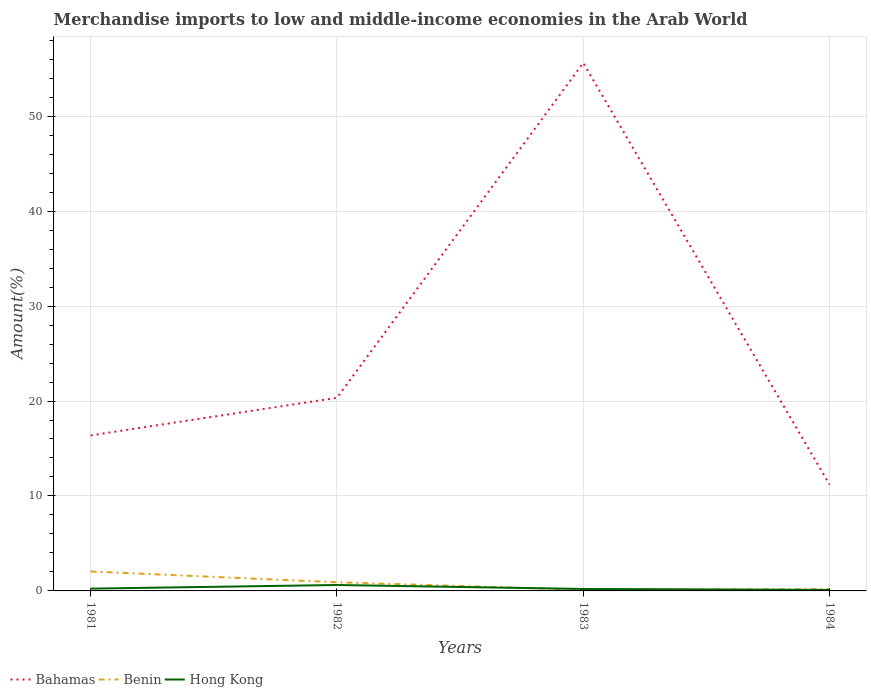How many different coloured lines are there?
Give a very brief answer. 3. Across all years, what is the maximum percentage of amount earned from merchandise imports in Bahamas?
Ensure brevity in your answer.  11.19. What is the total percentage of amount earned from merchandise imports in Hong Kong in the graph?
Offer a terse response. 0.52. What is the difference between the highest and the second highest percentage of amount earned from merchandise imports in Hong Kong?
Provide a short and direct response. 0.52. What is the difference between two consecutive major ticks on the Y-axis?
Ensure brevity in your answer.  10. Does the graph contain any zero values?
Offer a terse response. No. Does the graph contain grids?
Provide a succinct answer. Yes. How many legend labels are there?
Make the answer very short. 3. What is the title of the graph?
Your answer should be compact. Merchandise imports to low and middle-income economies in the Arab World. What is the label or title of the X-axis?
Keep it short and to the point. Years. What is the label or title of the Y-axis?
Give a very brief answer. Amount(%). What is the Amount(%) of Bahamas in 1981?
Your response must be concise. 16.38. What is the Amount(%) in Benin in 1981?
Your response must be concise. 2.05. What is the Amount(%) of Hong Kong in 1981?
Your answer should be very brief. 0.24. What is the Amount(%) in Bahamas in 1982?
Ensure brevity in your answer.  20.34. What is the Amount(%) of Benin in 1982?
Provide a short and direct response. 0.91. What is the Amount(%) of Hong Kong in 1982?
Ensure brevity in your answer.  0.62. What is the Amount(%) of Bahamas in 1983?
Provide a short and direct response. 55.61. What is the Amount(%) in Benin in 1983?
Provide a short and direct response. 0.13. What is the Amount(%) of Hong Kong in 1983?
Keep it short and to the point. 0.21. What is the Amount(%) in Bahamas in 1984?
Give a very brief answer. 11.19. What is the Amount(%) of Benin in 1984?
Make the answer very short. 0.18. What is the Amount(%) of Hong Kong in 1984?
Your answer should be very brief. 0.11. Across all years, what is the maximum Amount(%) in Bahamas?
Provide a short and direct response. 55.61. Across all years, what is the maximum Amount(%) in Benin?
Provide a succinct answer. 2.05. Across all years, what is the maximum Amount(%) in Hong Kong?
Provide a short and direct response. 0.62. Across all years, what is the minimum Amount(%) in Bahamas?
Your answer should be very brief. 11.19. Across all years, what is the minimum Amount(%) of Benin?
Keep it short and to the point. 0.13. Across all years, what is the minimum Amount(%) of Hong Kong?
Your answer should be compact. 0.11. What is the total Amount(%) in Bahamas in the graph?
Your answer should be compact. 103.52. What is the total Amount(%) in Benin in the graph?
Your answer should be compact. 3.27. What is the total Amount(%) in Hong Kong in the graph?
Keep it short and to the point. 1.18. What is the difference between the Amount(%) of Bahamas in 1981 and that in 1982?
Keep it short and to the point. -3.96. What is the difference between the Amount(%) in Benin in 1981 and that in 1982?
Your answer should be very brief. 1.14. What is the difference between the Amount(%) in Hong Kong in 1981 and that in 1982?
Keep it short and to the point. -0.38. What is the difference between the Amount(%) of Bahamas in 1981 and that in 1983?
Offer a very short reply. -39.23. What is the difference between the Amount(%) of Benin in 1981 and that in 1983?
Keep it short and to the point. 1.92. What is the difference between the Amount(%) in Hong Kong in 1981 and that in 1983?
Give a very brief answer. 0.03. What is the difference between the Amount(%) in Bahamas in 1981 and that in 1984?
Keep it short and to the point. 5.18. What is the difference between the Amount(%) in Benin in 1981 and that in 1984?
Keep it short and to the point. 1.87. What is the difference between the Amount(%) in Hong Kong in 1981 and that in 1984?
Your answer should be very brief. 0.13. What is the difference between the Amount(%) in Bahamas in 1982 and that in 1983?
Provide a short and direct response. -35.27. What is the difference between the Amount(%) of Benin in 1982 and that in 1983?
Provide a short and direct response. 0.78. What is the difference between the Amount(%) in Hong Kong in 1982 and that in 1983?
Offer a very short reply. 0.42. What is the difference between the Amount(%) of Bahamas in 1982 and that in 1984?
Provide a succinct answer. 9.15. What is the difference between the Amount(%) in Benin in 1982 and that in 1984?
Your answer should be very brief. 0.73. What is the difference between the Amount(%) of Hong Kong in 1982 and that in 1984?
Offer a terse response. 0.52. What is the difference between the Amount(%) in Bahamas in 1983 and that in 1984?
Your answer should be very brief. 44.41. What is the difference between the Amount(%) in Benin in 1983 and that in 1984?
Offer a very short reply. -0.05. What is the difference between the Amount(%) in Hong Kong in 1983 and that in 1984?
Offer a terse response. 0.1. What is the difference between the Amount(%) of Bahamas in 1981 and the Amount(%) of Benin in 1982?
Offer a terse response. 15.47. What is the difference between the Amount(%) in Bahamas in 1981 and the Amount(%) in Hong Kong in 1982?
Your answer should be compact. 15.75. What is the difference between the Amount(%) in Benin in 1981 and the Amount(%) in Hong Kong in 1982?
Ensure brevity in your answer.  1.43. What is the difference between the Amount(%) of Bahamas in 1981 and the Amount(%) of Benin in 1983?
Ensure brevity in your answer.  16.25. What is the difference between the Amount(%) in Bahamas in 1981 and the Amount(%) in Hong Kong in 1983?
Keep it short and to the point. 16.17. What is the difference between the Amount(%) in Benin in 1981 and the Amount(%) in Hong Kong in 1983?
Give a very brief answer. 1.84. What is the difference between the Amount(%) in Bahamas in 1981 and the Amount(%) in Benin in 1984?
Make the answer very short. 16.2. What is the difference between the Amount(%) in Bahamas in 1981 and the Amount(%) in Hong Kong in 1984?
Your answer should be very brief. 16.27. What is the difference between the Amount(%) in Benin in 1981 and the Amount(%) in Hong Kong in 1984?
Provide a short and direct response. 1.94. What is the difference between the Amount(%) of Bahamas in 1982 and the Amount(%) of Benin in 1983?
Offer a very short reply. 20.21. What is the difference between the Amount(%) of Bahamas in 1982 and the Amount(%) of Hong Kong in 1983?
Your response must be concise. 20.13. What is the difference between the Amount(%) of Benin in 1982 and the Amount(%) of Hong Kong in 1983?
Your response must be concise. 0.7. What is the difference between the Amount(%) of Bahamas in 1982 and the Amount(%) of Benin in 1984?
Provide a succinct answer. 20.16. What is the difference between the Amount(%) of Bahamas in 1982 and the Amount(%) of Hong Kong in 1984?
Offer a terse response. 20.23. What is the difference between the Amount(%) of Benin in 1982 and the Amount(%) of Hong Kong in 1984?
Make the answer very short. 0.81. What is the difference between the Amount(%) of Bahamas in 1983 and the Amount(%) of Benin in 1984?
Ensure brevity in your answer.  55.43. What is the difference between the Amount(%) of Bahamas in 1983 and the Amount(%) of Hong Kong in 1984?
Make the answer very short. 55.5. What is the difference between the Amount(%) in Benin in 1983 and the Amount(%) in Hong Kong in 1984?
Keep it short and to the point. 0.02. What is the average Amount(%) in Bahamas per year?
Ensure brevity in your answer.  25.88. What is the average Amount(%) of Benin per year?
Provide a short and direct response. 0.82. What is the average Amount(%) in Hong Kong per year?
Provide a short and direct response. 0.29. In the year 1981, what is the difference between the Amount(%) of Bahamas and Amount(%) of Benin?
Keep it short and to the point. 14.33. In the year 1981, what is the difference between the Amount(%) of Bahamas and Amount(%) of Hong Kong?
Keep it short and to the point. 16.14. In the year 1981, what is the difference between the Amount(%) of Benin and Amount(%) of Hong Kong?
Offer a terse response. 1.81. In the year 1982, what is the difference between the Amount(%) of Bahamas and Amount(%) of Benin?
Offer a terse response. 19.43. In the year 1982, what is the difference between the Amount(%) in Bahamas and Amount(%) in Hong Kong?
Give a very brief answer. 19.72. In the year 1982, what is the difference between the Amount(%) of Benin and Amount(%) of Hong Kong?
Your answer should be very brief. 0.29. In the year 1983, what is the difference between the Amount(%) in Bahamas and Amount(%) in Benin?
Ensure brevity in your answer.  55.48. In the year 1983, what is the difference between the Amount(%) of Bahamas and Amount(%) of Hong Kong?
Provide a short and direct response. 55.4. In the year 1983, what is the difference between the Amount(%) in Benin and Amount(%) in Hong Kong?
Ensure brevity in your answer.  -0.08. In the year 1984, what is the difference between the Amount(%) of Bahamas and Amount(%) of Benin?
Make the answer very short. 11.02. In the year 1984, what is the difference between the Amount(%) in Bahamas and Amount(%) in Hong Kong?
Offer a very short reply. 11.09. In the year 1984, what is the difference between the Amount(%) in Benin and Amount(%) in Hong Kong?
Provide a short and direct response. 0.07. What is the ratio of the Amount(%) in Bahamas in 1981 to that in 1982?
Provide a succinct answer. 0.81. What is the ratio of the Amount(%) in Benin in 1981 to that in 1982?
Your response must be concise. 2.25. What is the ratio of the Amount(%) in Hong Kong in 1981 to that in 1982?
Offer a very short reply. 0.39. What is the ratio of the Amount(%) of Bahamas in 1981 to that in 1983?
Provide a short and direct response. 0.29. What is the ratio of the Amount(%) in Benin in 1981 to that in 1983?
Provide a succinct answer. 16.12. What is the ratio of the Amount(%) in Hong Kong in 1981 to that in 1983?
Your answer should be compact. 1.16. What is the ratio of the Amount(%) in Bahamas in 1981 to that in 1984?
Provide a succinct answer. 1.46. What is the ratio of the Amount(%) of Benin in 1981 to that in 1984?
Your answer should be compact. 11.48. What is the ratio of the Amount(%) of Hong Kong in 1981 to that in 1984?
Offer a very short reply. 2.27. What is the ratio of the Amount(%) of Bahamas in 1982 to that in 1983?
Your response must be concise. 0.37. What is the ratio of the Amount(%) of Benin in 1982 to that in 1983?
Provide a short and direct response. 7.17. What is the ratio of the Amount(%) in Hong Kong in 1982 to that in 1983?
Your answer should be compact. 3. What is the ratio of the Amount(%) of Bahamas in 1982 to that in 1984?
Your response must be concise. 1.82. What is the ratio of the Amount(%) in Benin in 1982 to that in 1984?
Provide a short and direct response. 5.11. What is the ratio of the Amount(%) in Hong Kong in 1982 to that in 1984?
Your answer should be compact. 5.88. What is the ratio of the Amount(%) in Bahamas in 1983 to that in 1984?
Your response must be concise. 4.97. What is the ratio of the Amount(%) in Benin in 1983 to that in 1984?
Your answer should be very brief. 0.71. What is the ratio of the Amount(%) of Hong Kong in 1983 to that in 1984?
Your response must be concise. 1.96. What is the difference between the highest and the second highest Amount(%) in Bahamas?
Give a very brief answer. 35.27. What is the difference between the highest and the second highest Amount(%) of Benin?
Keep it short and to the point. 1.14. What is the difference between the highest and the second highest Amount(%) in Hong Kong?
Keep it short and to the point. 0.38. What is the difference between the highest and the lowest Amount(%) of Bahamas?
Your answer should be very brief. 44.41. What is the difference between the highest and the lowest Amount(%) in Benin?
Offer a terse response. 1.92. What is the difference between the highest and the lowest Amount(%) of Hong Kong?
Provide a short and direct response. 0.52. 